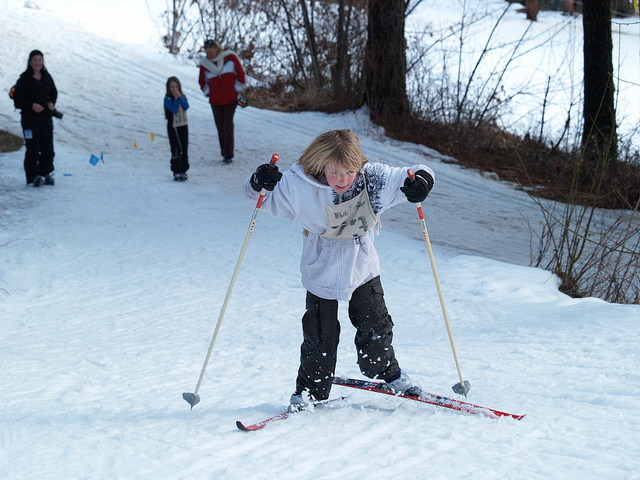<image>Which child uses poles? I am not sure which child uses poles. It can be the blonde kid or the girl in white and black. Which child uses poles? I don't know which child uses poles. It can be any of the children mentioned in the answers. 